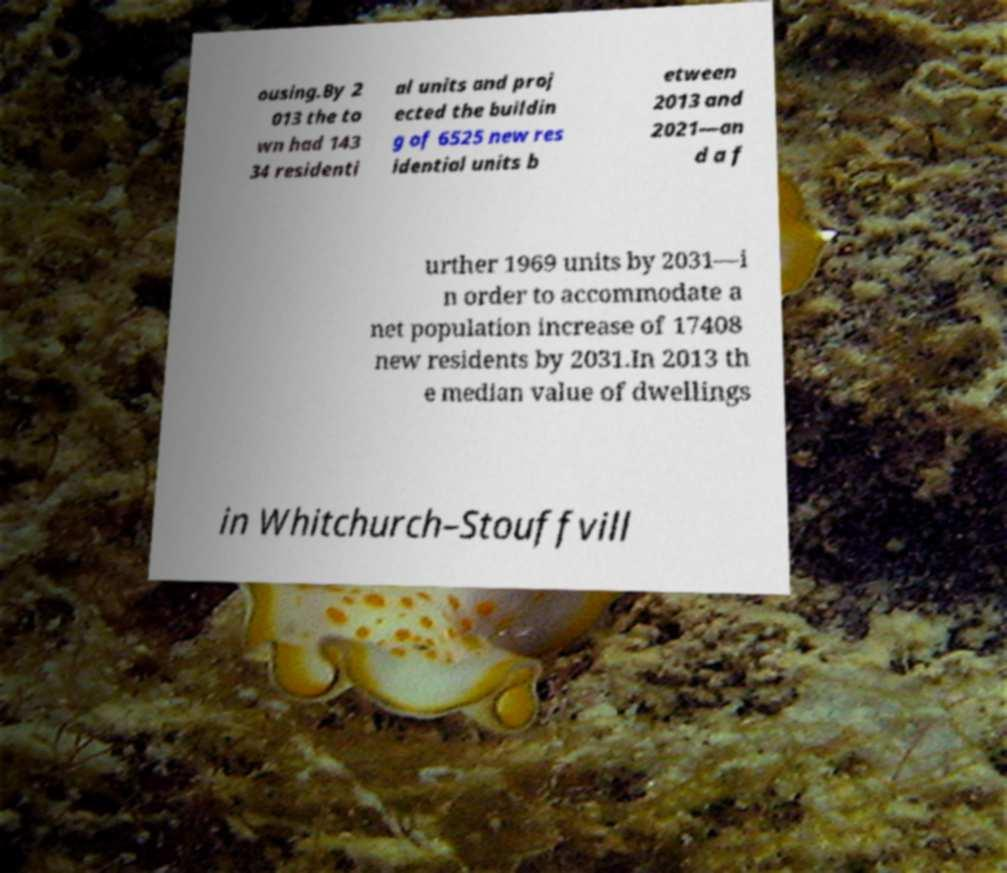Could you assist in decoding the text presented in this image and type it out clearly? ousing.By 2 013 the to wn had 143 34 residenti al units and proj ected the buildin g of 6525 new res idential units b etween 2013 and 2021—an d a f urther 1969 units by 2031—i n order to accommodate a net population increase of 17408 new residents by 2031.In 2013 th e median value of dwellings in Whitchurch–Stouffvill 